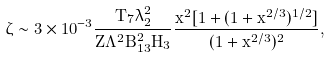<formula> <loc_0><loc_0><loc_500><loc_500>\zeta \sim 3 \times 1 0 ^ { - 3 } \frac { T _ { 7 } \lambda _ { 2 } ^ { 2 } } { Z \Lambda ^ { 2 } B _ { 1 3 } ^ { 2 } H _ { 3 } } \frac { x ^ { 2 } [ 1 + ( 1 + x ^ { 2 / 3 } ) ^ { 1 / 2 } ] } { ( 1 + x ^ { 2 / 3 } ) ^ { 2 } } ,</formula> 